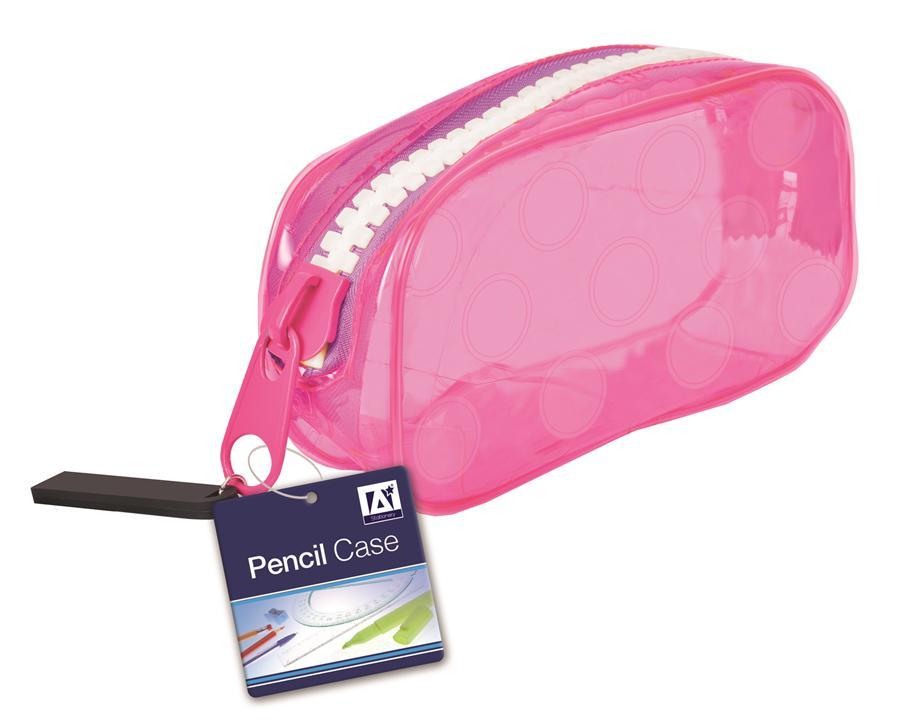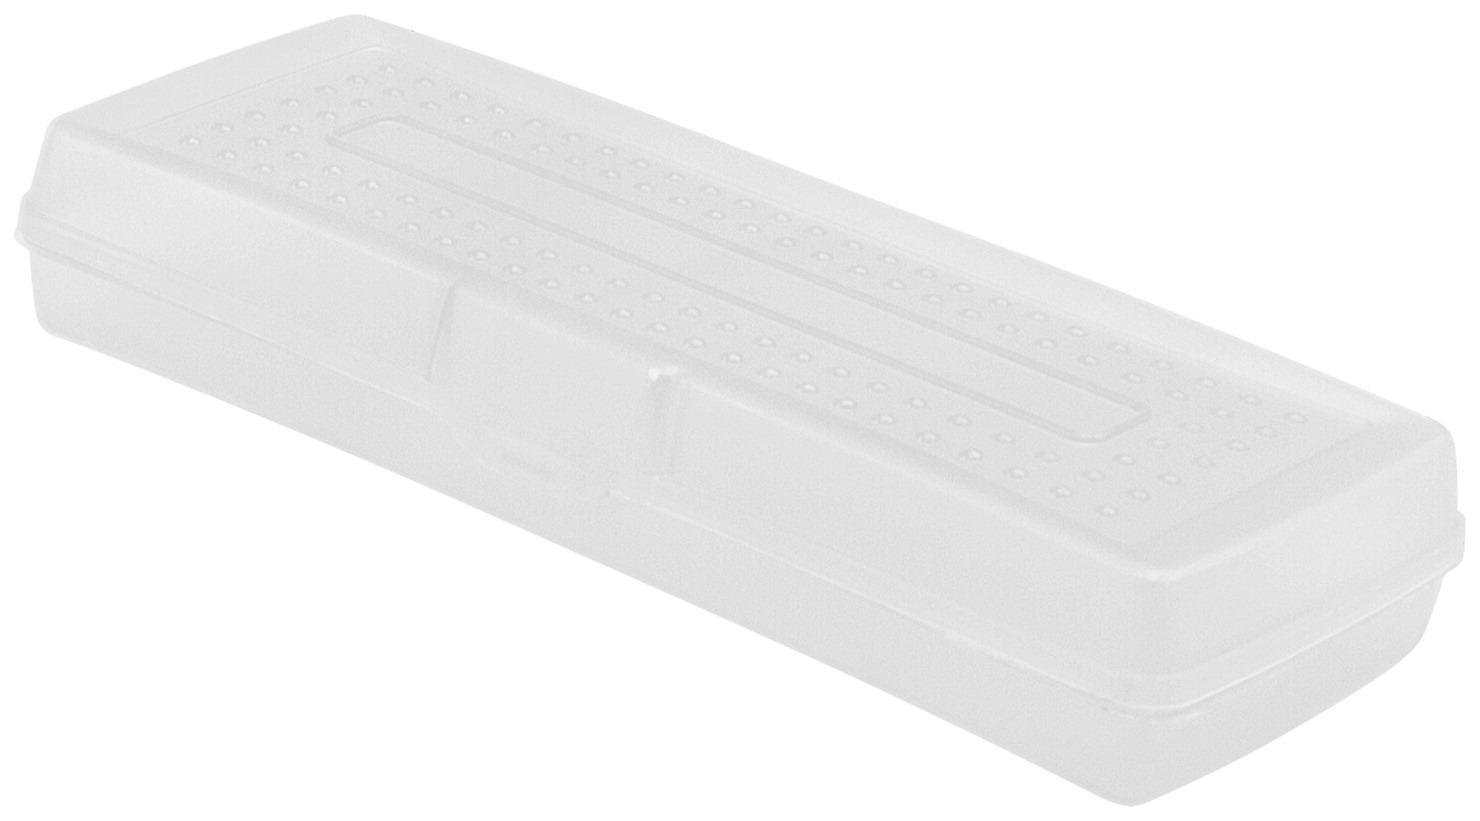The first image is the image on the left, the second image is the image on the right. Given the left and right images, does the statement "One clear pencil case has only a blue zipper on top, and one pencil case has at least a pink zipper across the top." hold true? Answer yes or no. No. The first image is the image on the left, the second image is the image on the right. Assess this claim about the two images: "There are 2 pencil cases, each with 1 zipper.". Correct or not? Answer yes or no. No. 